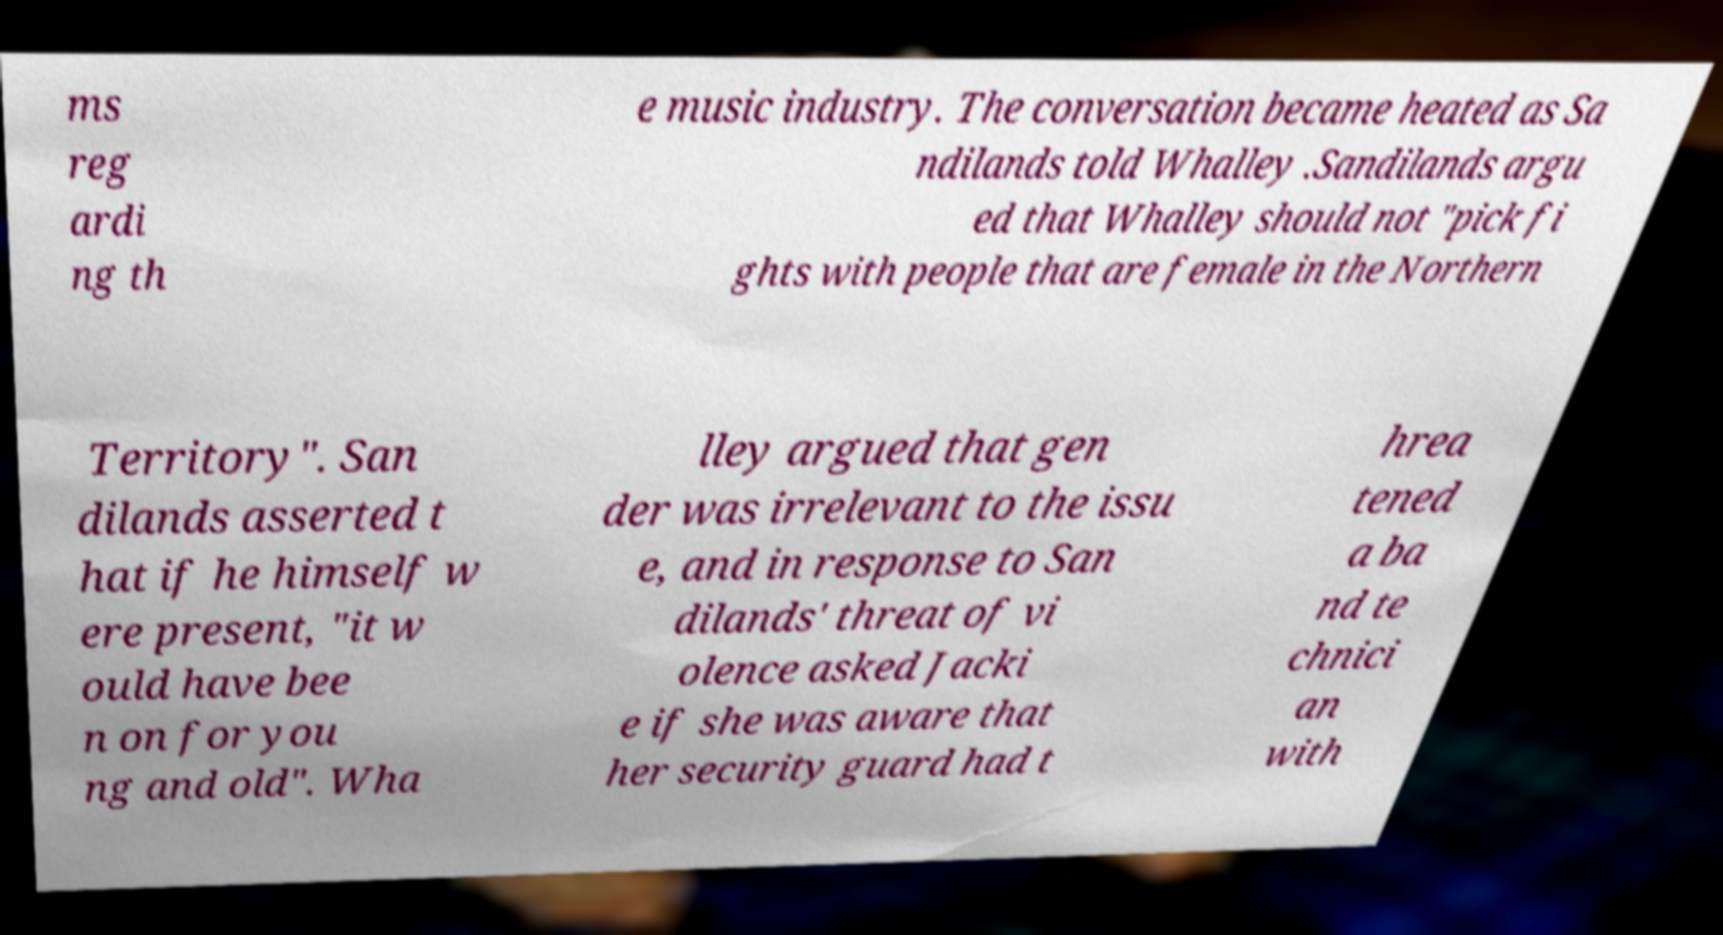What messages or text are displayed in this image? I need them in a readable, typed format. ms reg ardi ng th e music industry. The conversation became heated as Sa ndilands told Whalley .Sandilands argu ed that Whalley should not "pick fi ghts with people that are female in the Northern Territory". San dilands asserted t hat if he himself w ere present, "it w ould have bee n on for you ng and old". Wha lley argued that gen der was irrelevant to the issu e, and in response to San dilands' threat of vi olence asked Jacki e if she was aware that her security guard had t hrea tened a ba nd te chnici an with 